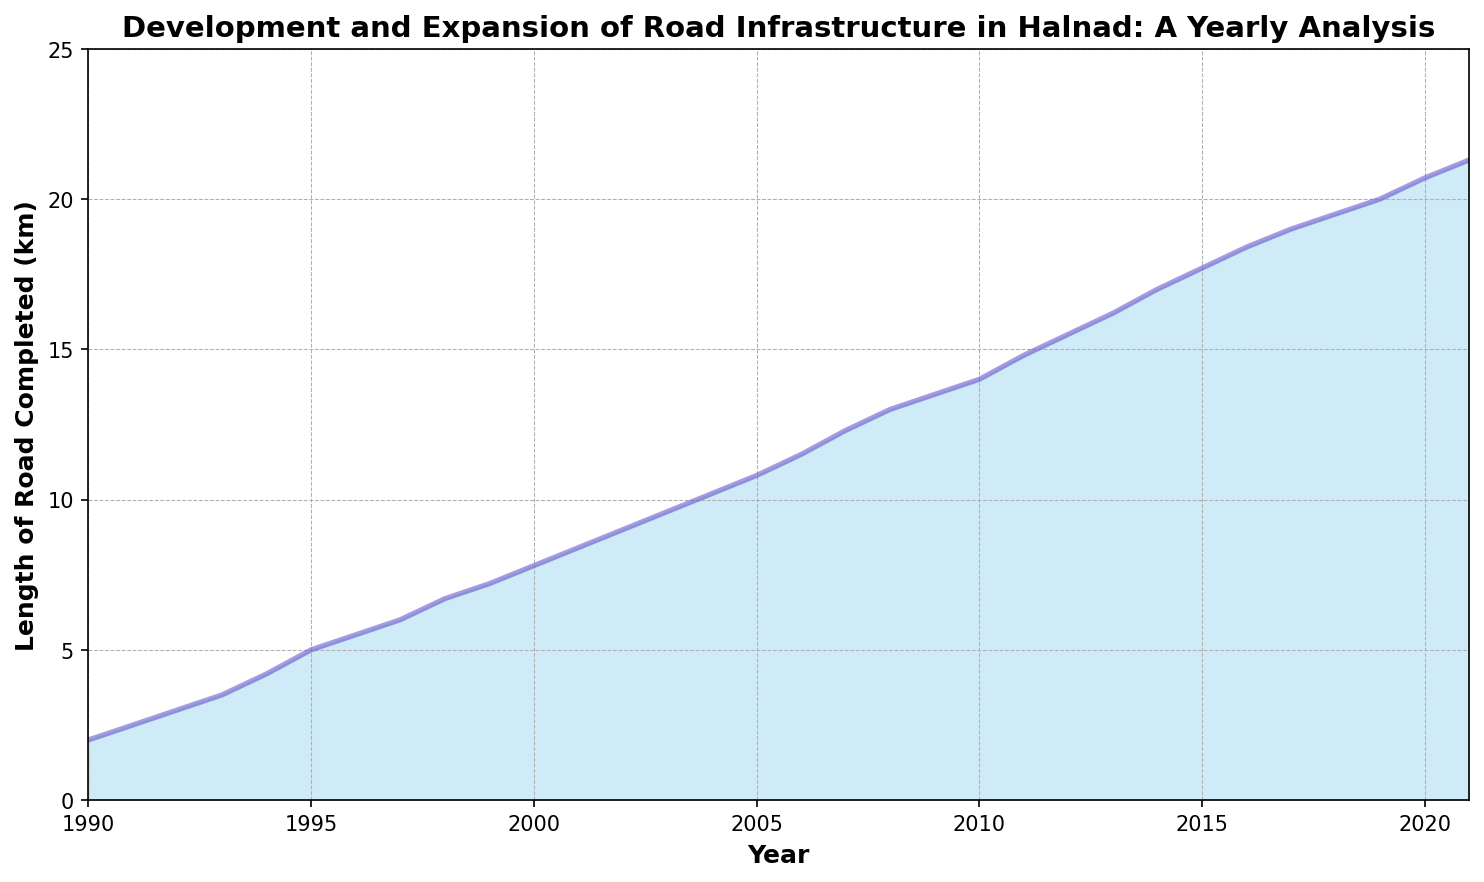What was the length of road completed in 2000? Look at the data point directly above the year 2000 on the x-axis to read the corresponding y-value.
Answer: 7.8 km During which decade did Halnad experience the most road development? Evaluate the overall increase in the length of road completed for each decade. The 2000s show a significant rise from around 7.8 km to 20 km.
Answer: 2000s Compare the length of road completed in 1990 versus 2021. By reading the figures at both moments on the x-axis, you'll see a rise from 2 km in 1990 to 21.3 km in 2021.
Answer: 1990 was 2 km, 2021 was 21.3 km What's the average length of road completed each year from 1990 to 2000? Sum the lengths for each year from 1990 to 2000 and divide by the number of years (11). (2 + 2.5 + 3 + 3.5 + 4.2 + 5 + 5.5 + 6 + 6.7 + 7.2 + 7.8) / 11 = 4.82 km
Answer: 4.82 km In which year did the length of road completed first exceed 15 km? Identify the crossing point above the 15 km mark on the y-axis and trace it to the respective year on the x-axis.
Answer: 2013 During which period did the length completed increase by exactly 1 km? Find the period where the difference between two consecutive years' road lengths is precisely 1 km, notably from 1999 (7.2 km) to 2000 (7.8 km).
Answer: 1999-2000 Did the rate of road completion always increase over the years? Examine the graph to see if there's any dip or stagnation in the yearly trends. The graph shows a general sustained rise with minor slow periods but no declines.
Answer: Yes, generally increasing What's the maximum increase in road length recorded between any two consecutive years? Check the data for the largest single-year jump in road development. The peak increase is from 14.8 km in 2011 to 15.5 km in 2012 (0.7 km).
Answer: 0.7 km 